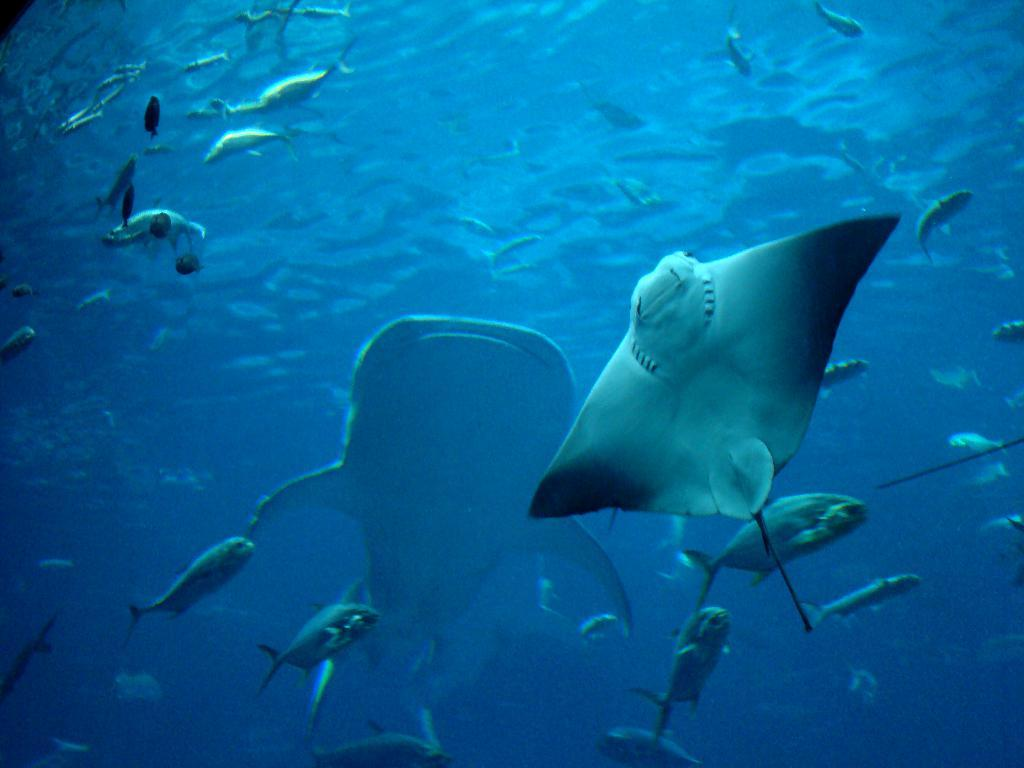What type of animals can be seen in the image? There are fishes in the image. Where are the fishes located? The fishes are in the water. What type of shelf can be seen in the image? There is no shelf present in the image; it features fishes in the water. What is the cause of the loss experienced by the fishes in the image? There is no indication of loss or any negative experience for the fishes in the image. 